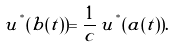Convert formula to latex. <formula><loc_0><loc_0><loc_500><loc_500>u ^ { ^ { * } } ( b ( t ) ) = \frac { 1 } { c } \, u ^ { ^ { * } } ( a ( t ) ) .</formula> 